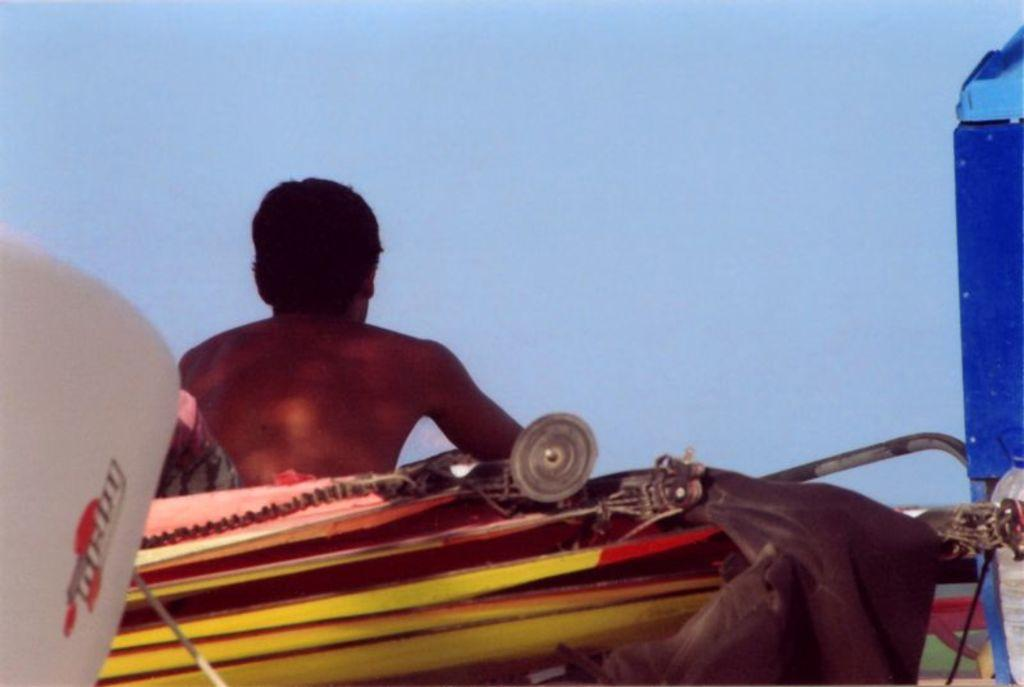What is the primary subject in the image? There is a person sitting in the image. What can be seen in the background of the image? The sky is visible in the background of the image. How many pigs are present in the image? There are no pigs present in the image; it features a person sitting and the sky in the background. 